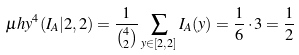Convert formula to latex. <formula><loc_0><loc_0><loc_500><loc_500>\mu h y ^ { 4 } ( I _ { A } | 2 , 2 ) = \frac { 1 } { \binom { 4 } { 2 } } \sum _ { y \in [ 2 , 2 ] } I _ { A } ( y ) = \frac { 1 } { 6 } \cdot 3 = \frac { 1 } { 2 }</formula> 